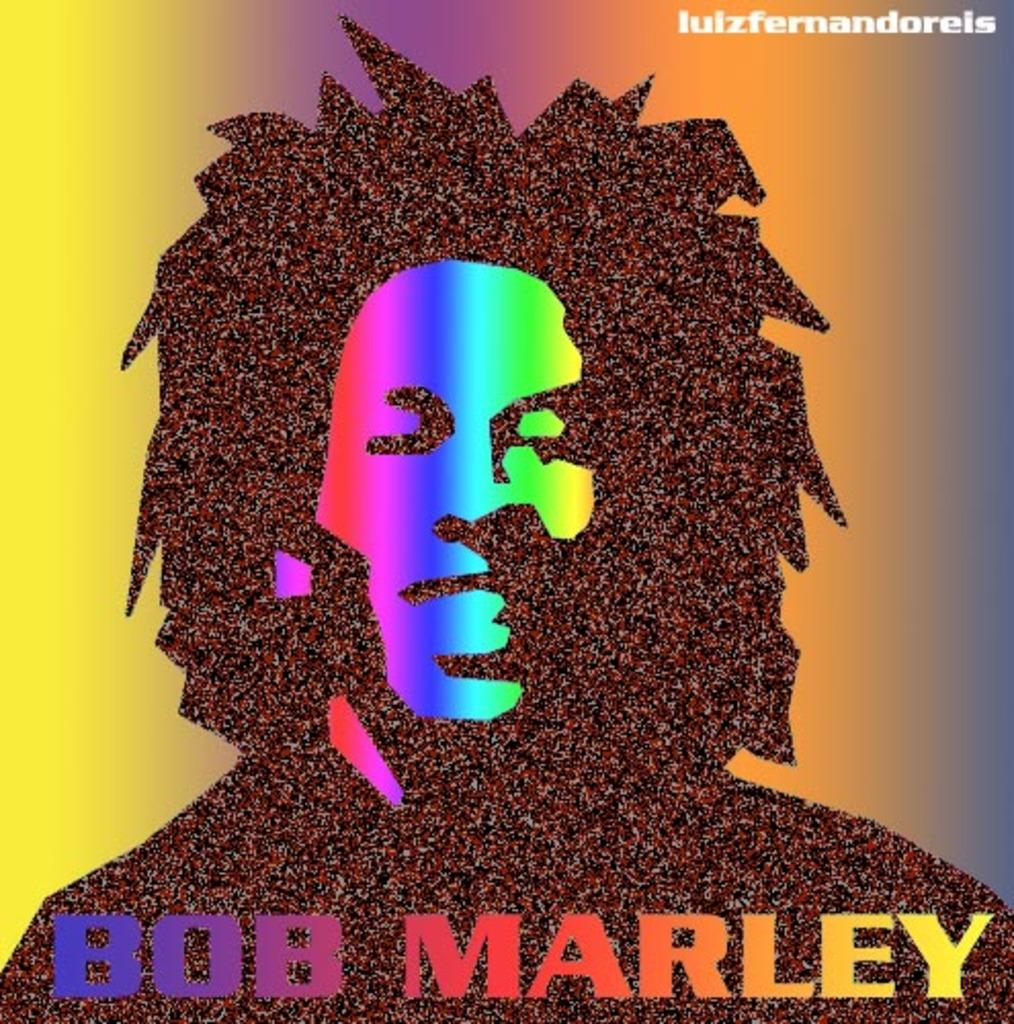<image>
Provide a brief description of the given image. Bob Marley is the artist pictured in this graphic. 